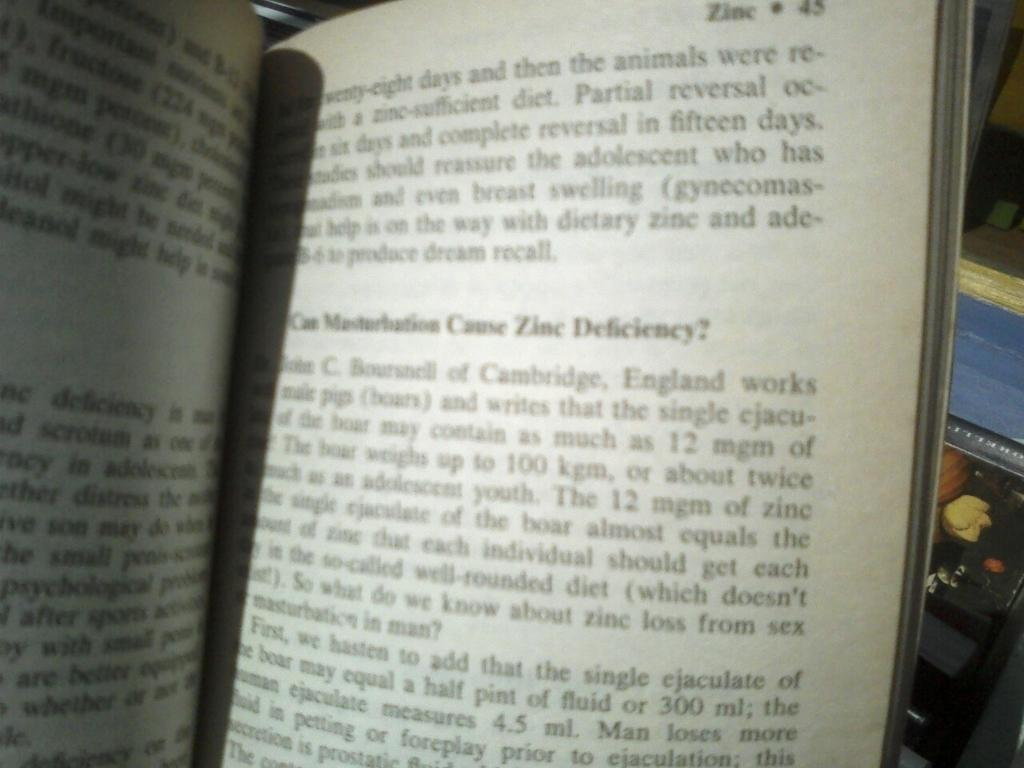<image>
Create a compact narrative representing the image presented. the word deficiency is in the page in the book 